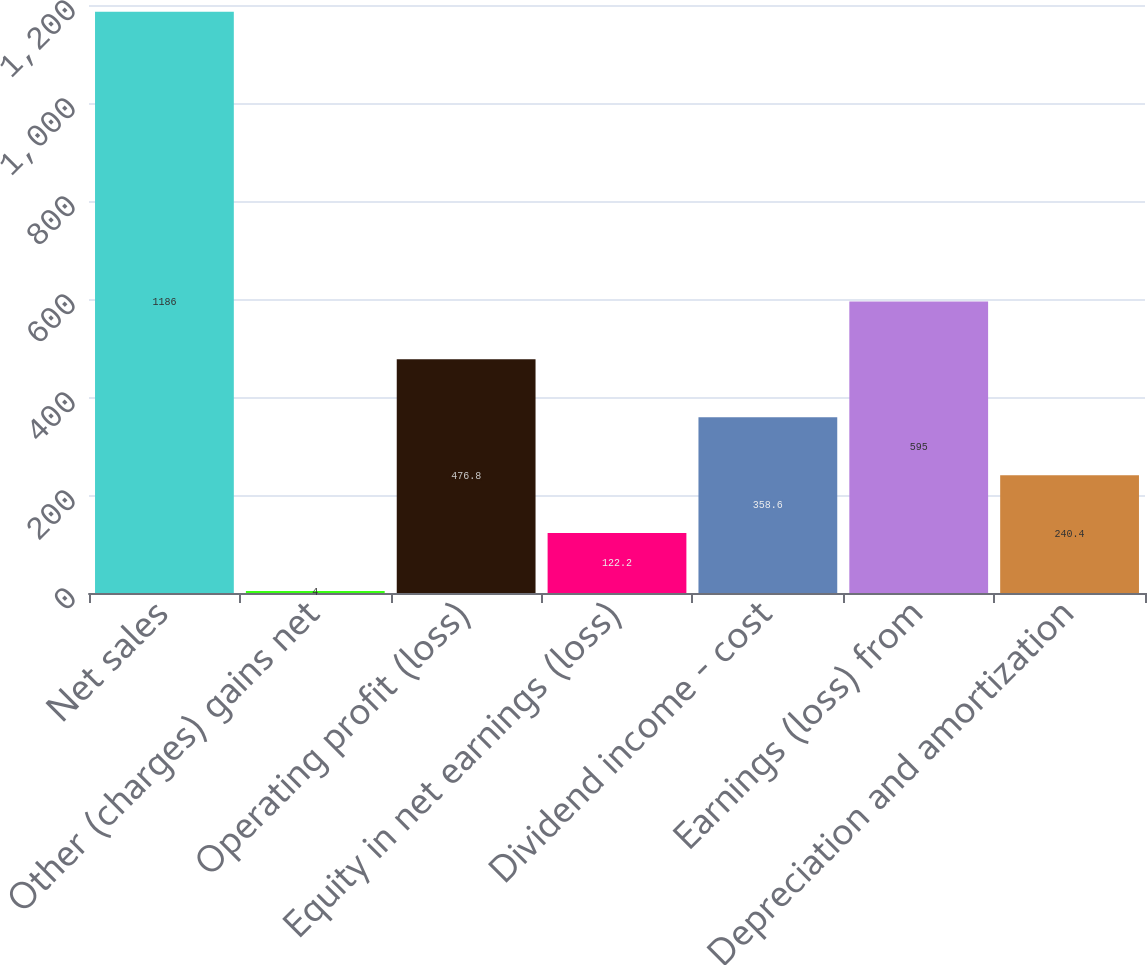Convert chart. <chart><loc_0><loc_0><loc_500><loc_500><bar_chart><fcel>Net sales<fcel>Other (charges) gains net<fcel>Operating profit (loss)<fcel>Equity in net earnings (loss)<fcel>Dividend income - cost<fcel>Earnings (loss) from<fcel>Depreciation and amortization<nl><fcel>1186<fcel>4<fcel>476.8<fcel>122.2<fcel>358.6<fcel>595<fcel>240.4<nl></chart> 